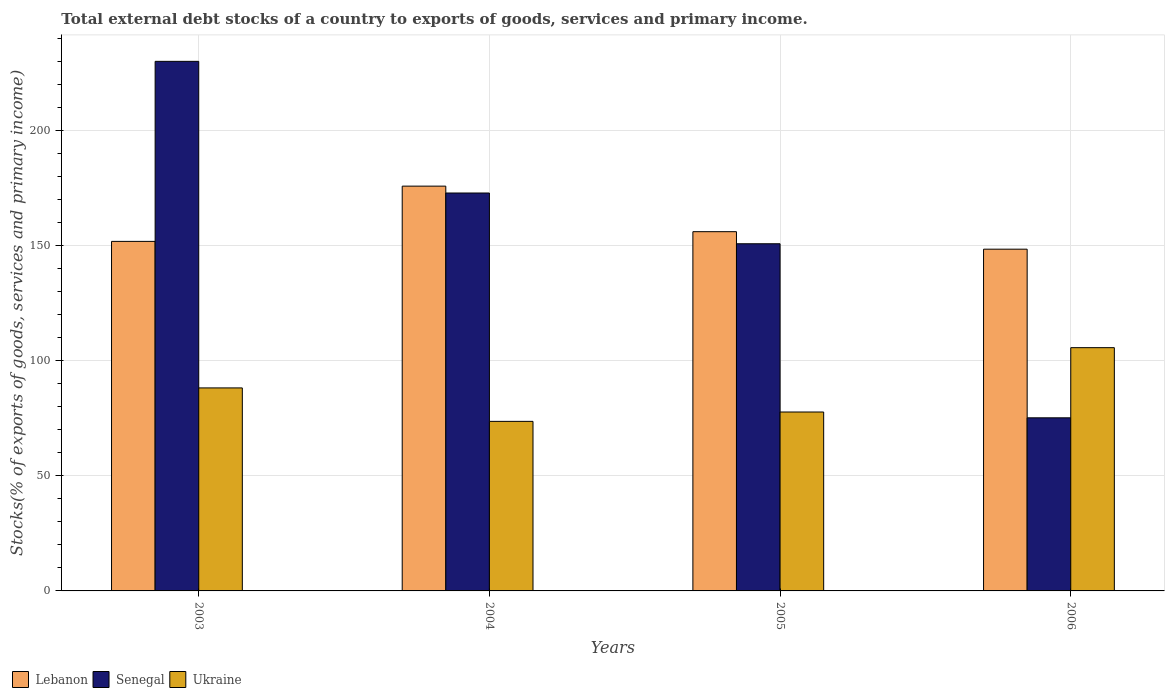Are the number of bars on each tick of the X-axis equal?
Your answer should be compact. Yes. How many bars are there on the 3rd tick from the left?
Make the answer very short. 3. In how many cases, is the number of bars for a given year not equal to the number of legend labels?
Your answer should be very brief. 0. What is the total debt stocks in Ukraine in 2006?
Your answer should be compact. 105.63. Across all years, what is the maximum total debt stocks in Ukraine?
Provide a succinct answer. 105.63. Across all years, what is the minimum total debt stocks in Senegal?
Your answer should be compact. 75.17. In which year was the total debt stocks in Senegal maximum?
Provide a short and direct response. 2003. In which year was the total debt stocks in Ukraine minimum?
Make the answer very short. 2004. What is the total total debt stocks in Ukraine in the graph?
Offer a very short reply. 345.11. What is the difference between the total debt stocks in Senegal in 2003 and that in 2005?
Keep it short and to the point. 79.21. What is the difference between the total debt stocks in Ukraine in 2005 and the total debt stocks in Lebanon in 2004?
Offer a terse response. -98.09. What is the average total debt stocks in Ukraine per year?
Offer a very short reply. 86.28. In the year 2003, what is the difference between the total debt stocks in Lebanon and total debt stocks in Senegal?
Offer a very short reply. -78.18. What is the ratio of the total debt stocks in Senegal in 2004 to that in 2006?
Provide a succinct answer. 2.3. Is the total debt stocks in Lebanon in 2003 less than that in 2005?
Keep it short and to the point. Yes. What is the difference between the highest and the second highest total debt stocks in Senegal?
Provide a short and direct response. 57.17. What is the difference between the highest and the lowest total debt stocks in Lebanon?
Make the answer very short. 27.38. In how many years, is the total debt stocks in Lebanon greater than the average total debt stocks in Lebanon taken over all years?
Your answer should be compact. 1. What does the 1st bar from the left in 2003 represents?
Give a very brief answer. Lebanon. What does the 1st bar from the right in 2003 represents?
Offer a terse response. Ukraine. How many bars are there?
Your response must be concise. 12. What is the difference between two consecutive major ticks on the Y-axis?
Your answer should be very brief. 50. Are the values on the major ticks of Y-axis written in scientific E-notation?
Provide a succinct answer. No. Does the graph contain any zero values?
Ensure brevity in your answer.  No. Does the graph contain grids?
Give a very brief answer. Yes. How many legend labels are there?
Provide a short and direct response. 3. How are the legend labels stacked?
Offer a very short reply. Horizontal. What is the title of the graph?
Give a very brief answer. Total external debt stocks of a country to exports of goods, services and primary income. What is the label or title of the Y-axis?
Give a very brief answer. Stocks(% of exports of goods, services and primary income). What is the Stocks(% of exports of goods, services and primary income) of Lebanon in 2003?
Offer a very short reply. 151.78. What is the Stocks(% of exports of goods, services and primary income) of Senegal in 2003?
Offer a terse response. 229.96. What is the Stocks(% of exports of goods, services and primary income) of Ukraine in 2003?
Ensure brevity in your answer.  88.16. What is the Stocks(% of exports of goods, services and primary income) of Lebanon in 2004?
Offer a terse response. 175.78. What is the Stocks(% of exports of goods, services and primary income) of Senegal in 2004?
Give a very brief answer. 172.79. What is the Stocks(% of exports of goods, services and primary income) of Ukraine in 2004?
Your answer should be very brief. 73.63. What is the Stocks(% of exports of goods, services and primary income) of Lebanon in 2005?
Give a very brief answer. 156. What is the Stocks(% of exports of goods, services and primary income) of Senegal in 2005?
Your answer should be very brief. 150.75. What is the Stocks(% of exports of goods, services and primary income) in Ukraine in 2005?
Provide a succinct answer. 77.69. What is the Stocks(% of exports of goods, services and primary income) of Lebanon in 2006?
Make the answer very short. 148.4. What is the Stocks(% of exports of goods, services and primary income) in Senegal in 2006?
Offer a very short reply. 75.17. What is the Stocks(% of exports of goods, services and primary income) in Ukraine in 2006?
Offer a terse response. 105.63. Across all years, what is the maximum Stocks(% of exports of goods, services and primary income) of Lebanon?
Your response must be concise. 175.78. Across all years, what is the maximum Stocks(% of exports of goods, services and primary income) in Senegal?
Provide a short and direct response. 229.96. Across all years, what is the maximum Stocks(% of exports of goods, services and primary income) in Ukraine?
Keep it short and to the point. 105.63. Across all years, what is the minimum Stocks(% of exports of goods, services and primary income) in Lebanon?
Your response must be concise. 148.4. Across all years, what is the minimum Stocks(% of exports of goods, services and primary income) of Senegal?
Your response must be concise. 75.17. Across all years, what is the minimum Stocks(% of exports of goods, services and primary income) of Ukraine?
Your answer should be compact. 73.63. What is the total Stocks(% of exports of goods, services and primary income) in Lebanon in the graph?
Ensure brevity in your answer.  631.96. What is the total Stocks(% of exports of goods, services and primary income) in Senegal in the graph?
Give a very brief answer. 628.68. What is the total Stocks(% of exports of goods, services and primary income) in Ukraine in the graph?
Your answer should be very brief. 345.11. What is the difference between the Stocks(% of exports of goods, services and primary income) of Lebanon in 2003 and that in 2004?
Offer a terse response. -23.99. What is the difference between the Stocks(% of exports of goods, services and primary income) of Senegal in 2003 and that in 2004?
Your answer should be very brief. 57.17. What is the difference between the Stocks(% of exports of goods, services and primary income) in Ukraine in 2003 and that in 2004?
Your answer should be compact. 14.53. What is the difference between the Stocks(% of exports of goods, services and primary income) in Lebanon in 2003 and that in 2005?
Your answer should be compact. -4.21. What is the difference between the Stocks(% of exports of goods, services and primary income) of Senegal in 2003 and that in 2005?
Your answer should be compact. 79.21. What is the difference between the Stocks(% of exports of goods, services and primary income) in Ukraine in 2003 and that in 2005?
Keep it short and to the point. 10.47. What is the difference between the Stocks(% of exports of goods, services and primary income) of Lebanon in 2003 and that in 2006?
Your response must be concise. 3.38. What is the difference between the Stocks(% of exports of goods, services and primary income) in Senegal in 2003 and that in 2006?
Provide a short and direct response. 154.79. What is the difference between the Stocks(% of exports of goods, services and primary income) in Ukraine in 2003 and that in 2006?
Your answer should be very brief. -17.48. What is the difference between the Stocks(% of exports of goods, services and primary income) in Lebanon in 2004 and that in 2005?
Keep it short and to the point. 19.78. What is the difference between the Stocks(% of exports of goods, services and primary income) of Senegal in 2004 and that in 2005?
Offer a very short reply. 22.04. What is the difference between the Stocks(% of exports of goods, services and primary income) in Ukraine in 2004 and that in 2005?
Provide a short and direct response. -4.06. What is the difference between the Stocks(% of exports of goods, services and primary income) of Lebanon in 2004 and that in 2006?
Make the answer very short. 27.38. What is the difference between the Stocks(% of exports of goods, services and primary income) of Senegal in 2004 and that in 2006?
Keep it short and to the point. 97.62. What is the difference between the Stocks(% of exports of goods, services and primary income) of Ukraine in 2004 and that in 2006?
Your answer should be very brief. -32. What is the difference between the Stocks(% of exports of goods, services and primary income) in Lebanon in 2005 and that in 2006?
Your answer should be compact. 7.6. What is the difference between the Stocks(% of exports of goods, services and primary income) in Senegal in 2005 and that in 2006?
Give a very brief answer. 75.58. What is the difference between the Stocks(% of exports of goods, services and primary income) of Ukraine in 2005 and that in 2006?
Offer a very short reply. -27.94. What is the difference between the Stocks(% of exports of goods, services and primary income) of Lebanon in 2003 and the Stocks(% of exports of goods, services and primary income) of Senegal in 2004?
Give a very brief answer. -21.01. What is the difference between the Stocks(% of exports of goods, services and primary income) in Lebanon in 2003 and the Stocks(% of exports of goods, services and primary income) in Ukraine in 2004?
Provide a succinct answer. 78.15. What is the difference between the Stocks(% of exports of goods, services and primary income) in Senegal in 2003 and the Stocks(% of exports of goods, services and primary income) in Ukraine in 2004?
Provide a short and direct response. 156.33. What is the difference between the Stocks(% of exports of goods, services and primary income) in Lebanon in 2003 and the Stocks(% of exports of goods, services and primary income) in Senegal in 2005?
Your answer should be very brief. 1.03. What is the difference between the Stocks(% of exports of goods, services and primary income) in Lebanon in 2003 and the Stocks(% of exports of goods, services and primary income) in Ukraine in 2005?
Your answer should be very brief. 74.09. What is the difference between the Stocks(% of exports of goods, services and primary income) in Senegal in 2003 and the Stocks(% of exports of goods, services and primary income) in Ukraine in 2005?
Offer a terse response. 152.27. What is the difference between the Stocks(% of exports of goods, services and primary income) of Lebanon in 2003 and the Stocks(% of exports of goods, services and primary income) of Senegal in 2006?
Provide a short and direct response. 76.61. What is the difference between the Stocks(% of exports of goods, services and primary income) in Lebanon in 2003 and the Stocks(% of exports of goods, services and primary income) in Ukraine in 2006?
Offer a terse response. 46.15. What is the difference between the Stocks(% of exports of goods, services and primary income) of Senegal in 2003 and the Stocks(% of exports of goods, services and primary income) of Ukraine in 2006?
Keep it short and to the point. 124.33. What is the difference between the Stocks(% of exports of goods, services and primary income) in Lebanon in 2004 and the Stocks(% of exports of goods, services and primary income) in Senegal in 2005?
Ensure brevity in your answer.  25.03. What is the difference between the Stocks(% of exports of goods, services and primary income) of Lebanon in 2004 and the Stocks(% of exports of goods, services and primary income) of Ukraine in 2005?
Offer a very short reply. 98.09. What is the difference between the Stocks(% of exports of goods, services and primary income) of Senegal in 2004 and the Stocks(% of exports of goods, services and primary income) of Ukraine in 2005?
Give a very brief answer. 95.1. What is the difference between the Stocks(% of exports of goods, services and primary income) of Lebanon in 2004 and the Stocks(% of exports of goods, services and primary income) of Senegal in 2006?
Offer a very short reply. 100.61. What is the difference between the Stocks(% of exports of goods, services and primary income) of Lebanon in 2004 and the Stocks(% of exports of goods, services and primary income) of Ukraine in 2006?
Provide a succinct answer. 70.14. What is the difference between the Stocks(% of exports of goods, services and primary income) in Senegal in 2004 and the Stocks(% of exports of goods, services and primary income) in Ukraine in 2006?
Keep it short and to the point. 67.16. What is the difference between the Stocks(% of exports of goods, services and primary income) of Lebanon in 2005 and the Stocks(% of exports of goods, services and primary income) of Senegal in 2006?
Your response must be concise. 80.83. What is the difference between the Stocks(% of exports of goods, services and primary income) in Lebanon in 2005 and the Stocks(% of exports of goods, services and primary income) in Ukraine in 2006?
Make the answer very short. 50.36. What is the difference between the Stocks(% of exports of goods, services and primary income) of Senegal in 2005 and the Stocks(% of exports of goods, services and primary income) of Ukraine in 2006?
Your answer should be compact. 45.12. What is the average Stocks(% of exports of goods, services and primary income) of Lebanon per year?
Ensure brevity in your answer.  157.99. What is the average Stocks(% of exports of goods, services and primary income) of Senegal per year?
Offer a very short reply. 157.17. What is the average Stocks(% of exports of goods, services and primary income) in Ukraine per year?
Ensure brevity in your answer.  86.28. In the year 2003, what is the difference between the Stocks(% of exports of goods, services and primary income) in Lebanon and Stocks(% of exports of goods, services and primary income) in Senegal?
Make the answer very short. -78.18. In the year 2003, what is the difference between the Stocks(% of exports of goods, services and primary income) of Lebanon and Stocks(% of exports of goods, services and primary income) of Ukraine?
Offer a terse response. 63.63. In the year 2003, what is the difference between the Stocks(% of exports of goods, services and primary income) of Senegal and Stocks(% of exports of goods, services and primary income) of Ukraine?
Offer a very short reply. 141.81. In the year 2004, what is the difference between the Stocks(% of exports of goods, services and primary income) of Lebanon and Stocks(% of exports of goods, services and primary income) of Senegal?
Ensure brevity in your answer.  2.99. In the year 2004, what is the difference between the Stocks(% of exports of goods, services and primary income) of Lebanon and Stocks(% of exports of goods, services and primary income) of Ukraine?
Offer a very short reply. 102.15. In the year 2004, what is the difference between the Stocks(% of exports of goods, services and primary income) of Senegal and Stocks(% of exports of goods, services and primary income) of Ukraine?
Your response must be concise. 99.16. In the year 2005, what is the difference between the Stocks(% of exports of goods, services and primary income) in Lebanon and Stocks(% of exports of goods, services and primary income) in Senegal?
Your answer should be compact. 5.25. In the year 2005, what is the difference between the Stocks(% of exports of goods, services and primary income) of Lebanon and Stocks(% of exports of goods, services and primary income) of Ukraine?
Your response must be concise. 78.31. In the year 2005, what is the difference between the Stocks(% of exports of goods, services and primary income) of Senegal and Stocks(% of exports of goods, services and primary income) of Ukraine?
Your response must be concise. 73.06. In the year 2006, what is the difference between the Stocks(% of exports of goods, services and primary income) in Lebanon and Stocks(% of exports of goods, services and primary income) in Senegal?
Your answer should be very brief. 73.23. In the year 2006, what is the difference between the Stocks(% of exports of goods, services and primary income) in Lebanon and Stocks(% of exports of goods, services and primary income) in Ukraine?
Keep it short and to the point. 42.77. In the year 2006, what is the difference between the Stocks(% of exports of goods, services and primary income) of Senegal and Stocks(% of exports of goods, services and primary income) of Ukraine?
Provide a succinct answer. -30.46. What is the ratio of the Stocks(% of exports of goods, services and primary income) in Lebanon in 2003 to that in 2004?
Keep it short and to the point. 0.86. What is the ratio of the Stocks(% of exports of goods, services and primary income) in Senegal in 2003 to that in 2004?
Provide a short and direct response. 1.33. What is the ratio of the Stocks(% of exports of goods, services and primary income) of Ukraine in 2003 to that in 2004?
Make the answer very short. 1.2. What is the ratio of the Stocks(% of exports of goods, services and primary income) of Lebanon in 2003 to that in 2005?
Your answer should be compact. 0.97. What is the ratio of the Stocks(% of exports of goods, services and primary income) of Senegal in 2003 to that in 2005?
Give a very brief answer. 1.53. What is the ratio of the Stocks(% of exports of goods, services and primary income) of Ukraine in 2003 to that in 2005?
Keep it short and to the point. 1.13. What is the ratio of the Stocks(% of exports of goods, services and primary income) of Lebanon in 2003 to that in 2006?
Provide a short and direct response. 1.02. What is the ratio of the Stocks(% of exports of goods, services and primary income) of Senegal in 2003 to that in 2006?
Ensure brevity in your answer.  3.06. What is the ratio of the Stocks(% of exports of goods, services and primary income) of Ukraine in 2003 to that in 2006?
Offer a terse response. 0.83. What is the ratio of the Stocks(% of exports of goods, services and primary income) of Lebanon in 2004 to that in 2005?
Provide a succinct answer. 1.13. What is the ratio of the Stocks(% of exports of goods, services and primary income) in Senegal in 2004 to that in 2005?
Give a very brief answer. 1.15. What is the ratio of the Stocks(% of exports of goods, services and primary income) of Ukraine in 2004 to that in 2005?
Offer a terse response. 0.95. What is the ratio of the Stocks(% of exports of goods, services and primary income) of Lebanon in 2004 to that in 2006?
Keep it short and to the point. 1.18. What is the ratio of the Stocks(% of exports of goods, services and primary income) of Senegal in 2004 to that in 2006?
Provide a short and direct response. 2.3. What is the ratio of the Stocks(% of exports of goods, services and primary income) in Ukraine in 2004 to that in 2006?
Offer a very short reply. 0.7. What is the ratio of the Stocks(% of exports of goods, services and primary income) in Lebanon in 2005 to that in 2006?
Give a very brief answer. 1.05. What is the ratio of the Stocks(% of exports of goods, services and primary income) in Senegal in 2005 to that in 2006?
Your response must be concise. 2.01. What is the ratio of the Stocks(% of exports of goods, services and primary income) in Ukraine in 2005 to that in 2006?
Offer a terse response. 0.74. What is the difference between the highest and the second highest Stocks(% of exports of goods, services and primary income) in Lebanon?
Provide a succinct answer. 19.78. What is the difference between the highest and the second highest Stocks(% of exports of goods, services and primary income) in Senegal?
Offer a terse response. 57.17. What is the difference between the highest and the second highest Stocks(% of exports of goods, services and primary income) of Ukraine?
Your response must be concise. 17.48. What is the difference between the highest and the lowest Stocks(% of exports of goods, services and primary income) in Lebanon?
Your answer should be very brief. 27.38. What is the difference between the highest and the lowest Stocks(% of exports of goods, services and primary income) of Senegal?
Provide a succinct answer. 154.79. What is the difference between the highest and the lowest Stocks(% of exports of goods, services and primary income) in Ukraine?
Provide a short and direct response. 32. 